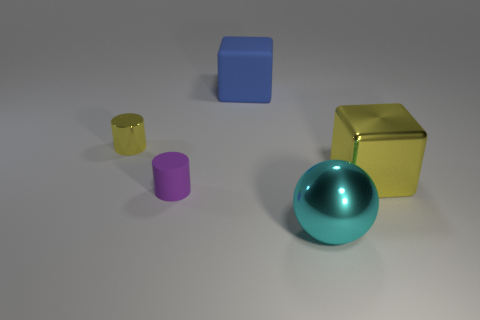What material is the small object in front of the metallic object that is behind the large yellow object?
Your answer should be very brief. Rubber. The metallic block is what color?
Make the answer very short. Yellow. There is a big metal object behind the purple object; does it have the same color as the cylinder that is left of the tiny matte cylinder?
Your answer should be compact. Yes. There is a yellow metallic thing that is the same shape as the purple object; what size is it?
Provide a short and direct response. Small. Are there any other small things of the same color as the tiny metallic object?
Your response must be concise. No. There is a big block that is the same color as the metal cylinder; what material is it?
Keep it short and to the point. Metal. What number of metal cylinders are the same color as the big shiny block?
Make the answer very short. 1. How many things are large metallic objects in front of the purple thing or blocks?
Make the answer very short. 3. There is a cube that is the same material as the tiny yellow cylinder; what color is it?
Your response must be concise. Yellow. Is there a cylinder of the same size as the purple object?
Keep it short and to the point. Yes. 